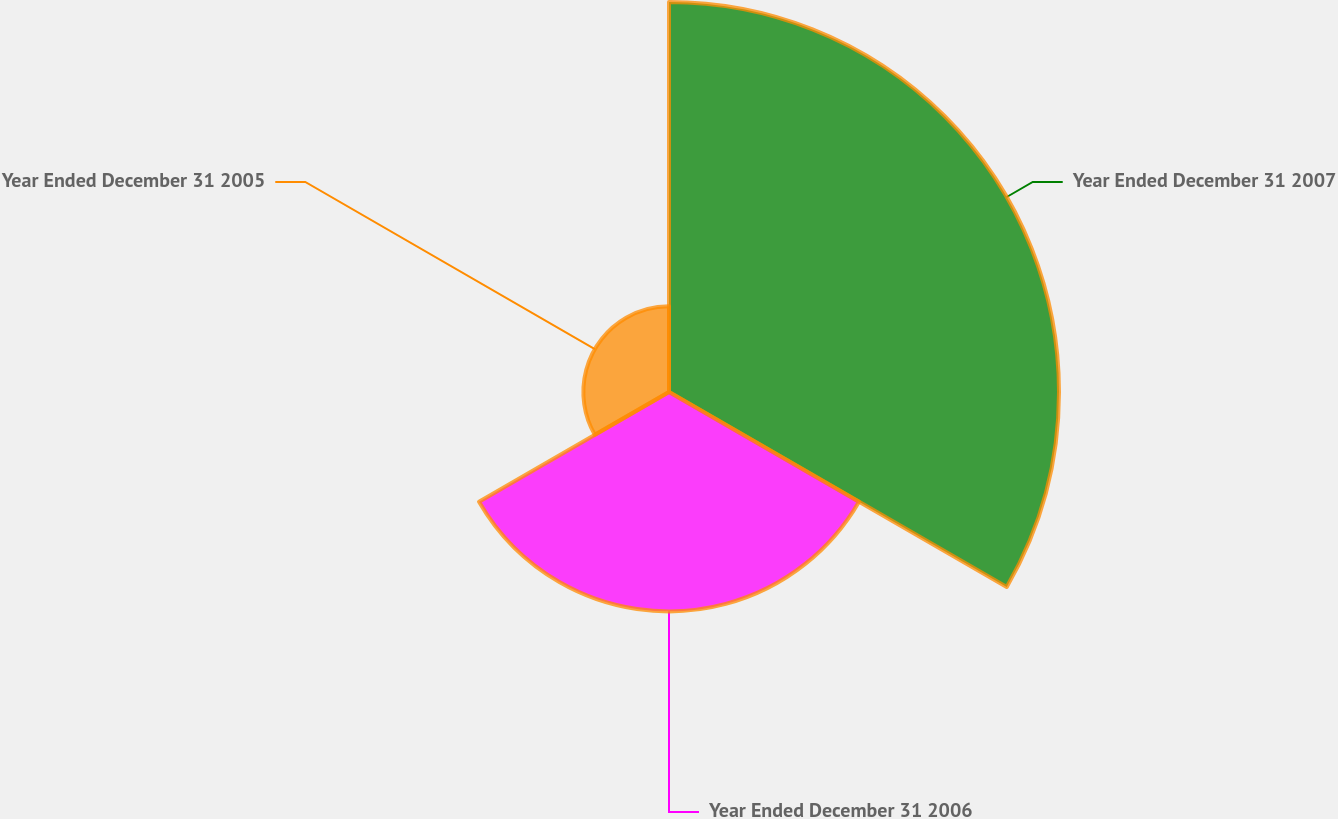Convert chart. <chart><loc_0><loc_0><loc_500><loc_500><pie_chart><fcel>Year Ended December 31 2007<fcel>Year Ended December 31 2006<fcel>Year Ended December 31 2005<nl><fcel>56.11%<fcel>31.56%<fcel>12.32%<nl></chart> 